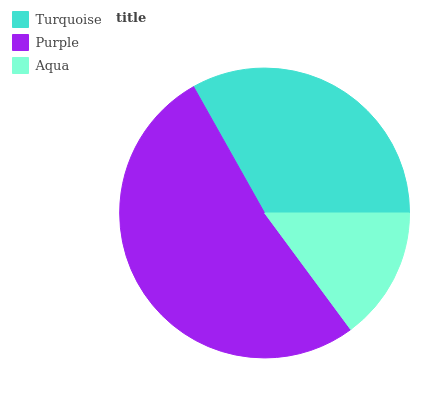Is Aqua the minimum?
Answer yes or no. Yes. Is Purple the maximum?
Answer yes or no. Yes. Is Purple the minimum?
Answer yes or no. No. Is Aqua the maximum?
Answer yes or no. No. Is Purple greater than Aqua?
Answer yes or no. Yes. Is Aqua less than Purple?
Answer yes or no. Yes. Is Aqua greater than Purple?
Answer yes or no. No. Is Purple less than Aqua?
Answer yes or no. No. Is Turquoise the high median?
Answer yes or no. Yes. Is Turquoise the low median?
Answer yes or no. Yes. Is Purple the high median?
Answer yes or no. No. Is Purple the low median?
Answer yes or no. No. 